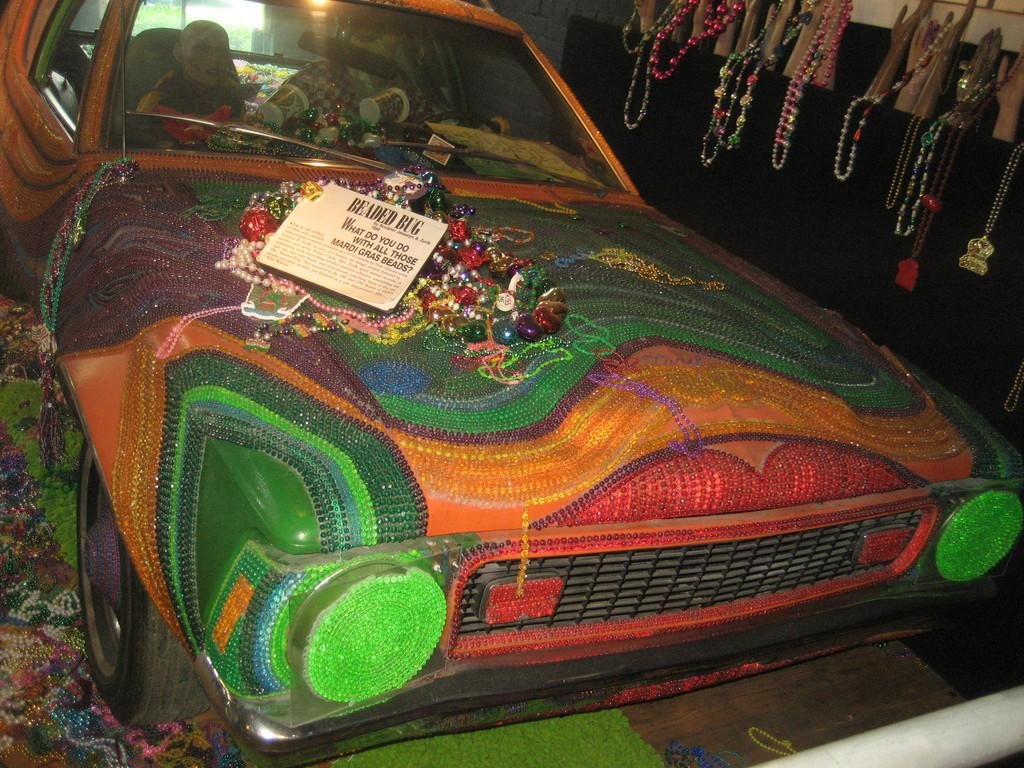What is the main subject of the picture? The main subject of the picture is a car. How is the car decorated? The car is decorated with beads. What else can be seen on the car? There are chains placed on the car. Where are the necklaces displayed in the image? The necklaces are displayed on the right side of the car. What type of question is being asked by the carpenter in the image? There is no carpenter present in the image, and therefore no such question can be observed. 